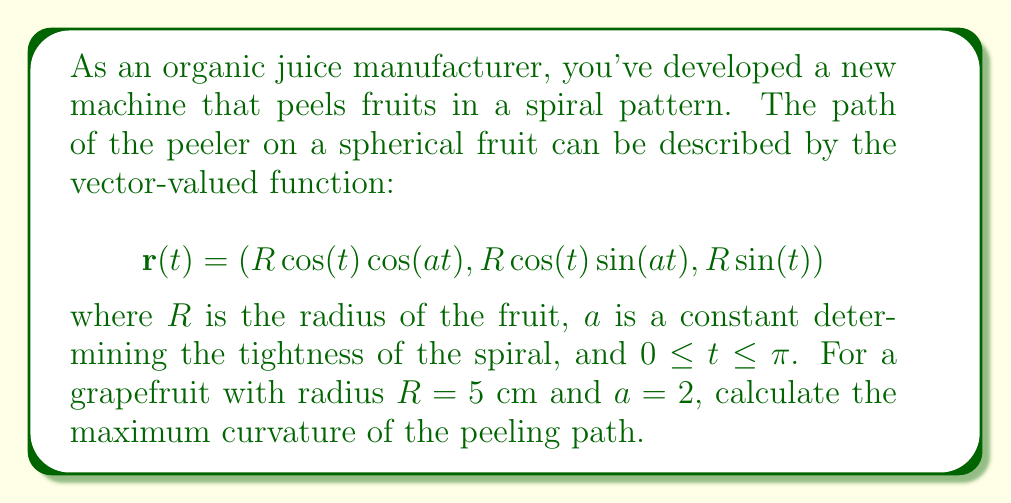Can you answer this question? To find the maximum curvature of the peeling path, we need to follow these steps:

1) First, we need to calculate $\mathbf{r}'(t)$ and $\mathbf{r}''(t)$:

   $$\mathbf{r}'(t) = (-R\sin(t)\cos(at) - aR\cos(t)\sin(at), -R\sin(t)\sin(at) + aR\cos(t)\cos(at), R\cos(t))$$
   
   $$\mathbf{r}''(t) = (-R\cos(t)\cos(at) + 2aR\sin(t)\sin(at) - a^2R\cos(t)\cos(at),$$
   $$-R\cos(t)\sin(at) - 2aR\sin(t)\cos(at) - a^2R\cos(t)\sin(at), -R\sin(t))$$

2) The curvature formula for a vector-valued function is:

   $$\kappa(t) = \frac{|\mathbf{r}'(t) \times \mathbf{r}''(t)|}{|\mathbf{r}'(t)|^3}$$

3) Calculate $|\mathbf{r}'(t)|$:

   $$|\mathbf{r}'(t)| = \sqrt{R^2\sin^2(t) + a^2R^2\cos^2(t) + R^2\cos^2(t)} = R\sqrt{1 + a^2\cos^2(t)}$$

4) Calculate $\mathbf{r}'(t) \times \mathbf{r}''(t)$:

   After cross multiplication and simplification, we get:
   
   $$\mathbf{r}'(t) \times \mathbf{r}''(t) = (aR^3\cos^3(t), aR^3\cos^3(t), a^2R^3\cos^3(t))$$

5) Calculate $|\mathbf{r}'(t) \times \mathbf{r}''(t)|$:

   $$|\mathbf{r}'(t) \times \mathbf{r}''(t)| = aR^3|\cos^3(t)|\sqrt{2 + a^2}$$

6) Now we can write the curvature function:

   $$\kappa(t) = \frac{aR^3|\cos^3(t)|\sqrt{2 + a^2}}{R^3(1 + a^2\cos^2(t))^{3/2}} = \frac{a|\cos^3(t)|\sqrt{2 + a^2}}{(1 + a^2\cos^2(t))^{3/2}}$$

7) To find the maximum curvature, we need to find the maximum value of this function. The maximum will occur when $|\cos(t)| = 1$, i.e., when $t = 0$ or $t = \pi$.

8) Substituting these values and our given values ($R = 5$, $a = 2$):

   $$\kappa_{max} = \frac{2\sqrt{6}}{(1 + 4)^{3/2}} = \frac{2\sqrt{6}}{125} \approx 0.0391$$

Therefore, the maximum curvature of the peeling path is approximately 0.0391 cm^(-1).
Answer: $\frac{2\sqrt{6}}{125}$ cm^(-1) 